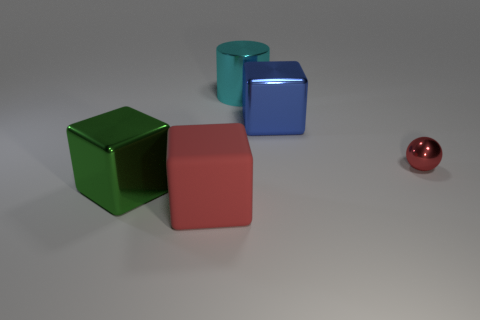Add 3 purple spheres. How many objects exist? 8 Subtract all blocks. How many objects are left? 2 Subtract all big green metallic things. Subtract all green objects. How many objects are left? 3 Add 3 large green metal blocks. How many large green metal blocks are left? 4 Add 1 large cubes. How many large cubes exist? 4 Subtract 0 brown cylinders. How many objects are left? 5 